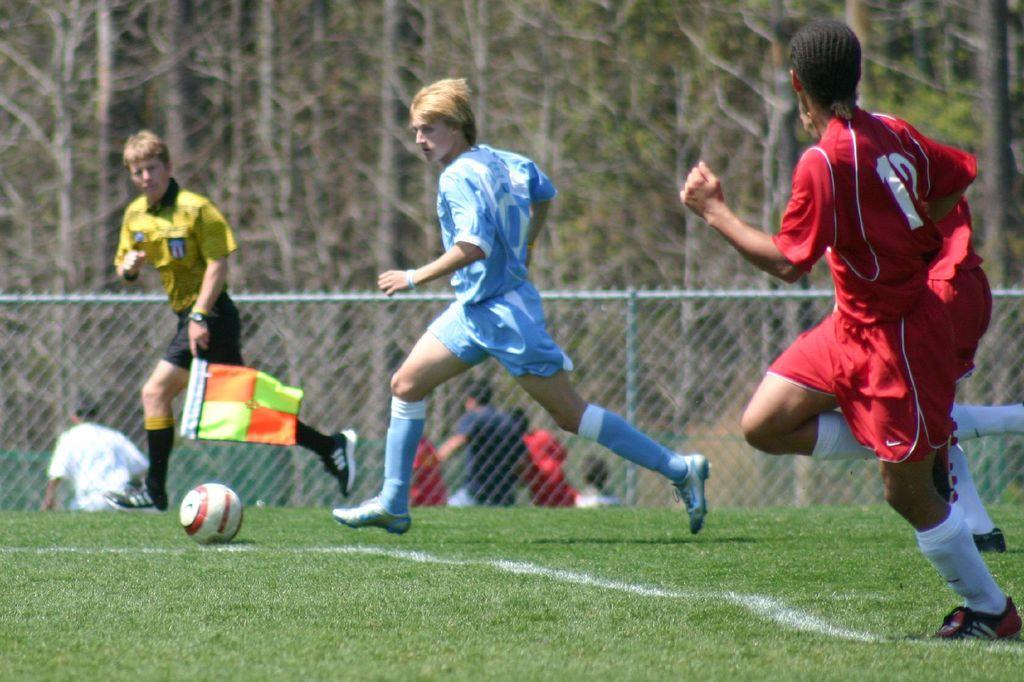What sport are the players in the image participating in? The players are playing football. Where is the football game taking place? The football game is taking place on a ground. Can you describe the background of the players in the image? The background of the players is blurred. Who is the expert in the image providing advice to the players? There is no expert present in the image; it only shows the players playing football. 